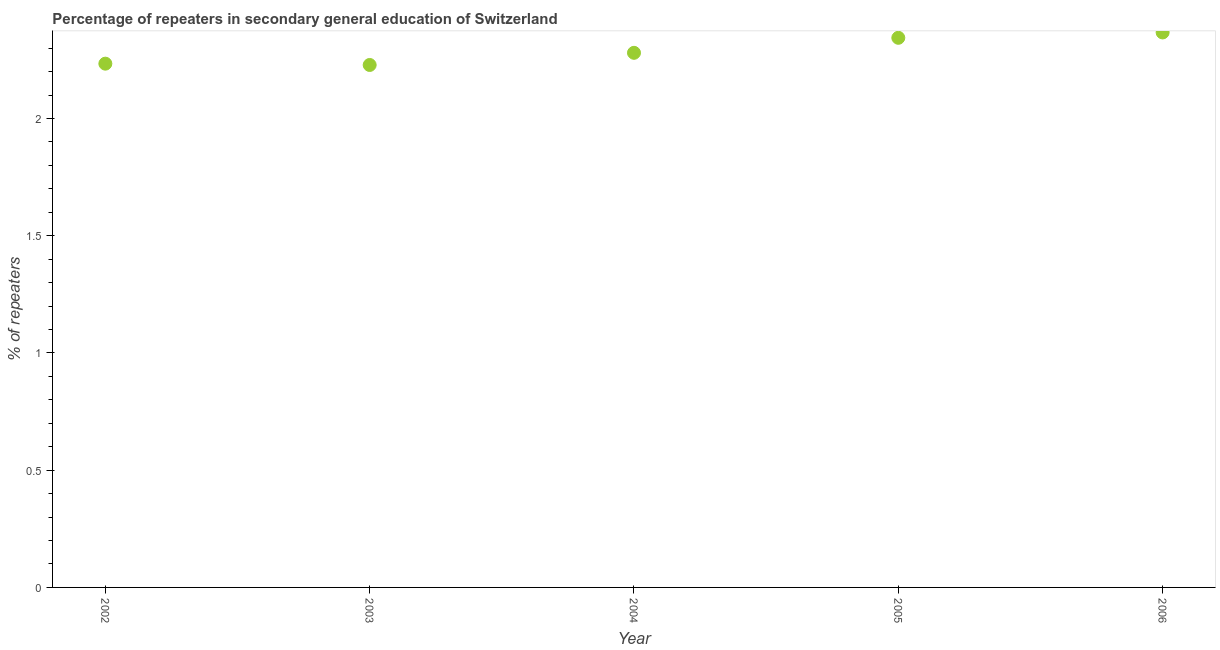What is the percentage of repeaters in 2005?
Your response must be concise. 2.34. Across all years, what is the maximum percentage of repeaters?
Give a very brief answer. 2.37. Across all years, what is the minimum percentage of repeaters?
Offer a terse response. 2.23. In which year was the percentage of repeaters maximum?
Provide a short and direct response. 2006. What is the sum of the percentage of repeaters?
Your answer should be very brief. 11.45. What is the difference between the percentage of repeaters in 2003 and 2006?
Provide a succinct answer. -0.14. What is the average percentage of repeaters per year?
Give a very brief answer. 2.29. What is the median percentage of repeaters?
Give a very brief answer. 2.28. Do a majority of the years between 2006 and 2002 (inclusive) have percentage of repeaters greater than 0.4 %?
Your response must be concise. Yes. What is the ratio of the percentage of repeaters in 2002 to that in 2003?
Your answer should be very brief. 1. Is the percentage of repeaters in 2003 less than that in 2005?
Your answer should be compact. Yes. What is the difference between the highest and the second highest percentage of repeaters?
Your answer should be compact. 0.02. Is the sum of the percentage of repeaters in 2004 and 2006 greater than the maximum percentage of repeaters across all years?
Your answer should be very brief. Yes. What is the difference between the highest and the lowest percentage of repeaters?
Offer a very short reply. 0.14. How many dotlines are there?
Make the answer very short. 1. How many years are there in the graph?
Ensure brevity in your answer.  5. Does the graph contain any zero values?
Keep it short and to the point. No. What is the title of the graph?
Provide a short and direct response. Percentage of repeaters in secondary general education of Switzerland. What is the label or title of the Y-axis?
Offer a very short reply. % of repeaters. What is the % of repeaters in 2002?
Give a very brief answer. 2.23. What is the % of repeaters in 2003?
Offer a terse response. 2.23. What is the % of repeaters in 2004?
Your answer should be very brief. 2.28. What is the % of repeaters in 2005?
Provide a short and direct response. 2.34. What is the % of repeaters in 2006?
Your response must be concise. 2.37. What is the difference between the % of repeaters in 2002 and 2003?
Your response must be concise. 0.01. What is the difference between the % of repeaters in 2002 and 2004?
Make the answer very short. -0.05. What is the difference between the % of repeaters in 2002 and 2005?
Provide a short and direct response. -0.11. What is the difference between the % of repeaters in 2002 and 2006?
Offer a terse response. -0.13. What is the difference between the % of repeaters in 2003 and 2004?
Provide a short and direct response. -0.05. What is the difference between the % of repeaters in 2003 and 2005?
Your answer should be very brief. -0.12. What is the difference between the % of repeaters in 2003 and 2006?
Keep it short and to the point. -0.14. What is the difference between the % of repeaters in 2004 and 2005?
Keep it short and to the point. -0.06. What is the difference between the % of repeaters in 2004 and 2006?
Provide a short and direct response. -0.09. What is the difference between the % of repeaters in 2005 and 2006?
Keep it short and to the point. -0.02. What is the ratio of the % of repeaters in 2002 to that in 2004?
Offer a terse response. 0.98. What is the ratio of the % of repeaters in 2002 to that in 2005?
Your answer should be very brief. 0.95. What is the ratio of the % of repeaters in 2002 to that in 2006?
Provide a short and direct response. 0.94. What is the ratio of the % of repeaters in 2003 to that in 2005?
Provide a succinct answer. 0.95. What is the ratio of the % of repeaters in 2003 to that in 2006?
Your answer should be very brief. 0.94. What is the ratio of the % of repeaters in 2005 to that in 2006?
Make the answer very short. 0.99. 